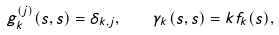<formula> <loc_0><loc_0><loc_500><loc_500>g _ { k } ^ { ( j ) } ( s , s ) = \delta _ { k , j } , \quad \gamma _ { k } ( s , s ) = k f _ { k } ( s ) ,</formula> 